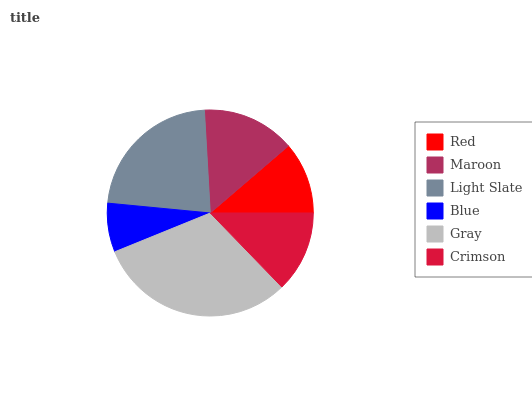Is Blue the minimum?
Answer yes or no. Yes. Is Gray the maximum?
Answer yes or no. Yes. Is Maroon the minimum?
Answer yes or no. No. Is Maroon the maximum?
Answer yes or no. No. Is Maroon greater than Red?
Answer yes or no. Yes. Is Red less than Maroon?
Answer yes or no. Yes. Is Red greater than Maroon?
Answer yes or no. No. Is Maroon less than Red?
Answer yes or no. No. Is Maroon the high median?
Answer yes or no. Yes. Is Crimson the low median?
Answer yes or no. Yes. Is Crimson the high median?
Answer yes or no. No. Is Red the low median?
Answer yes or no. No. 